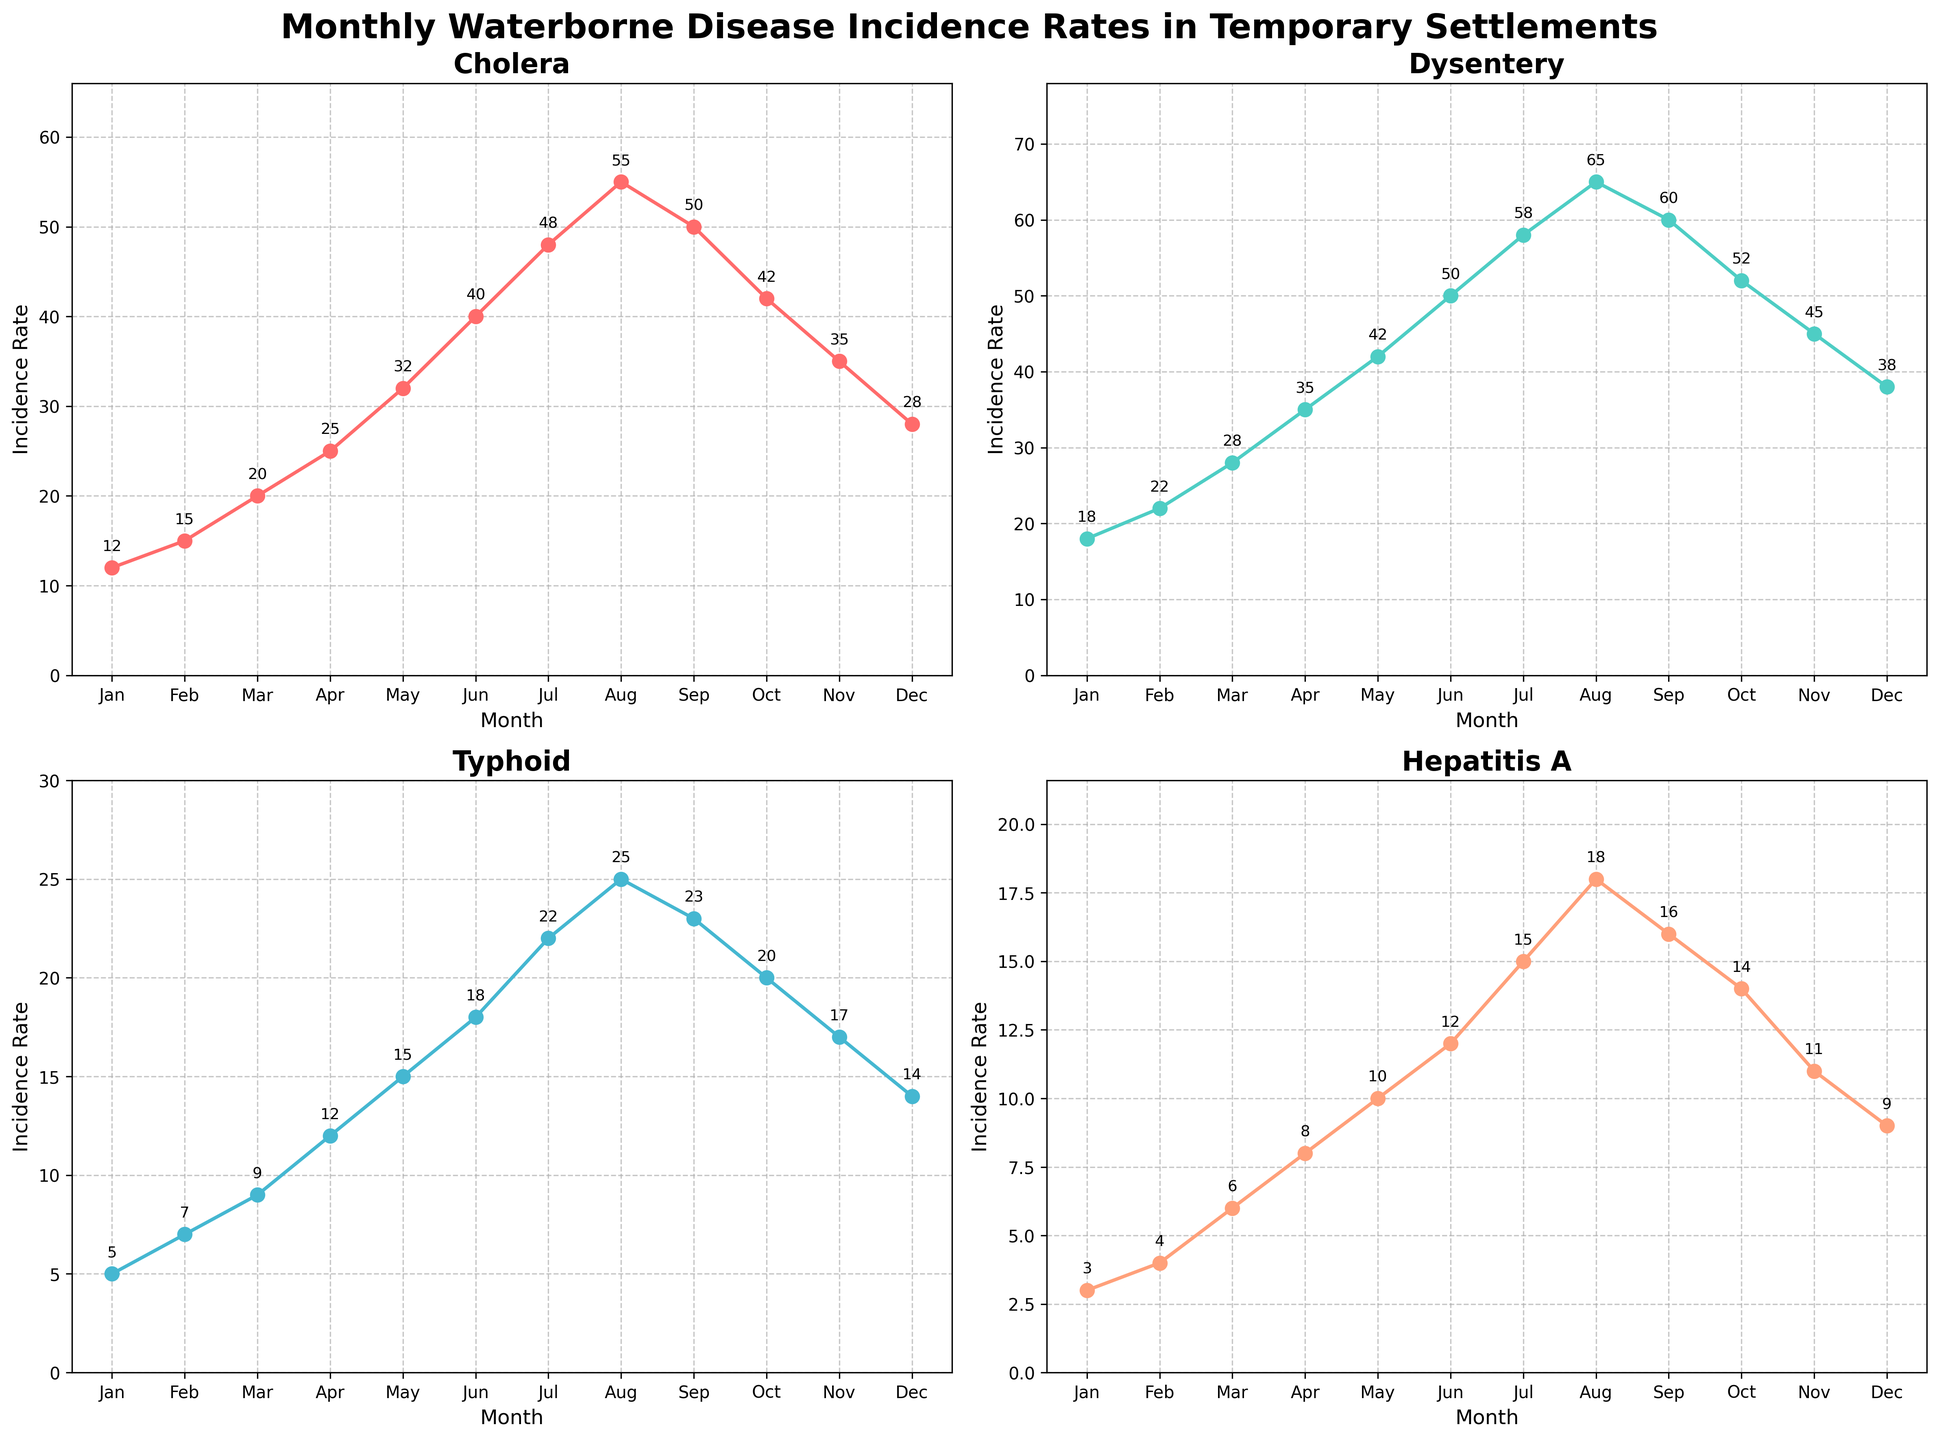What's the peak incidence rate for Cholera? According to the Cholera subplot in the rendered figure, the peak incidence rate can be found at the maximum value on the y-axis for that line. The highest incidence rate for Cholera occurs in August, with a value of 55
Answer: 55 During which month does Dysentery experience the highest incidence rate? By observing the Dysentery subplot, you can see that the incidence rate is highest when it reaches its maximum value on the plot line. This peak occurs in August, where the incidence rate is 65
Answer: August Compare the incidence rates of Hepatitis A and Typhoid in April. Which disease has a higher incidence rate, and by how much? Referring to the subplots for Hepatitis A and Typhoid in April, Hepatitis A has an incidence rate of 8, while Typhoid has an incidence rate of 12. Subtracting the smaller value from the larger value (12 - 8), Typhoid has a 4 units higher incidence rate in April
Answer: Typhoid, by 4 What is the average incidence rate of Cholera from January to December? To find the average incidence rate for Cholera, sum up all monthly incidence rates (12+15+20+25+32+40+48+55+50+42+35+28) and divide by the number of months (12). This equals 402 / 12, which rounds to 33.5
Answer: 33.5 In which month do all four diseases (Cholera, Dysentery, Typhoid, Hepatitis A) have the closest incidence rates to each other? By comparing the subplots for all four diseases, the month where the incidence rates are closest to each other can be found by observing the lines' proximity. In January, all diseases have relatively low incidence rates and are closer to each other: Cholera (12), Dysentery (18), Typhoid (5), and Hepatitis A (3). This month shows the smallest spread between the highest and the lowest values
Answer: January 